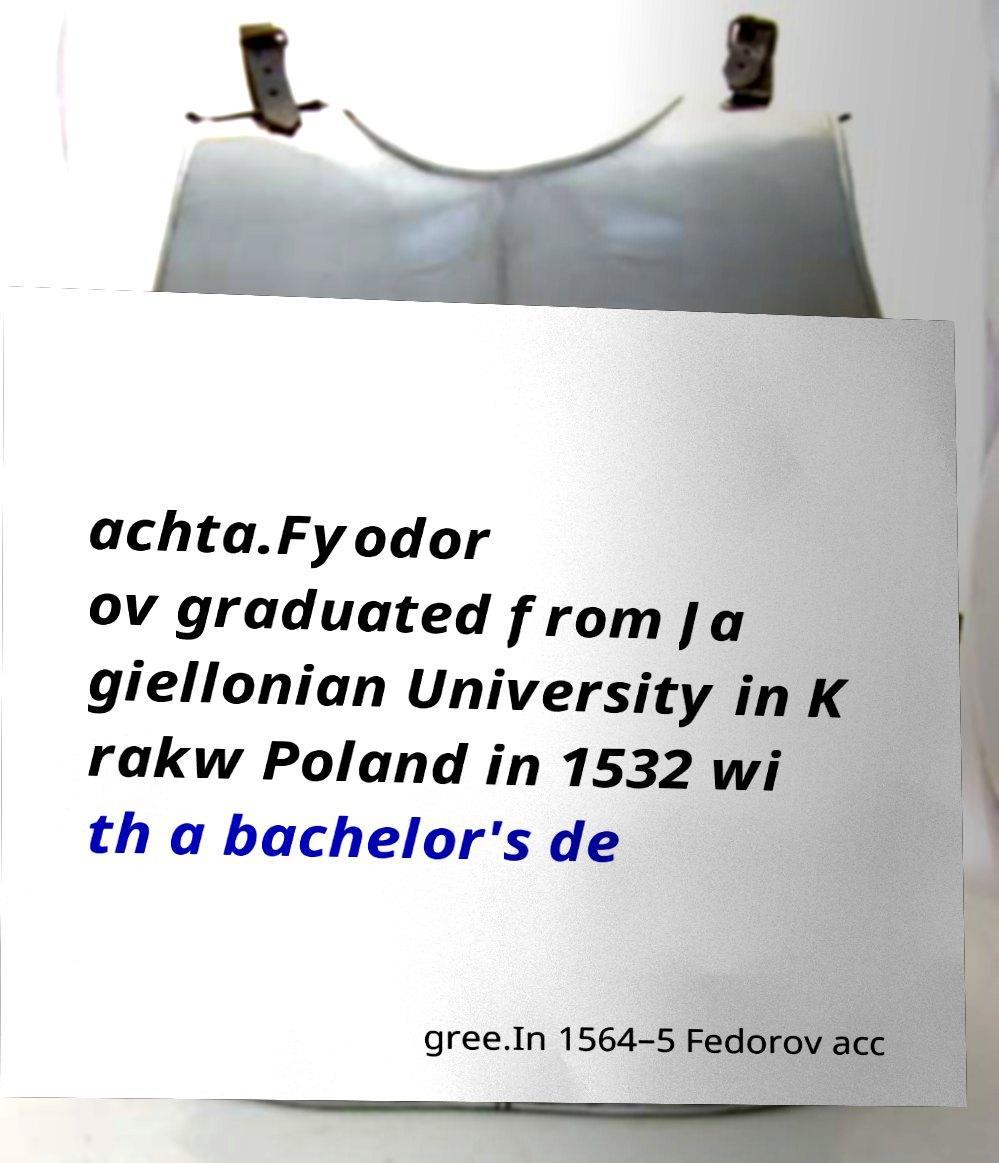Could you extract and type out the text from this image? achta.Fyodor ov graduated from Ja giellonian University in K rakw Poland in 1532 wi th a bachelor's de gree.In 1564–5 Fedorov acc 